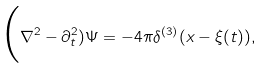<formula> <loc_0><loc_0><loc_500><loc_500>\Big ( \nabla ^ { 2 } - \partial ^ { 2 } _ { t } ) \Psi = - 4 \pi \delta ^ { ( 3 ) } ( x - \xi ( t ) ) ,</formula> 